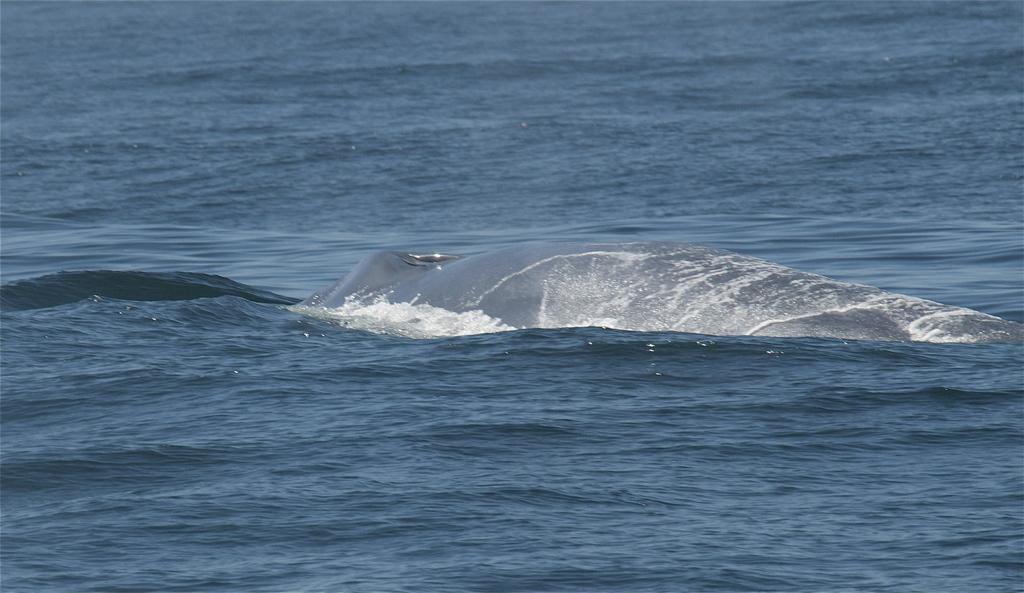Describe this image in one or two sentences. In this image there is an ocean, in that ocean there is one shark. 